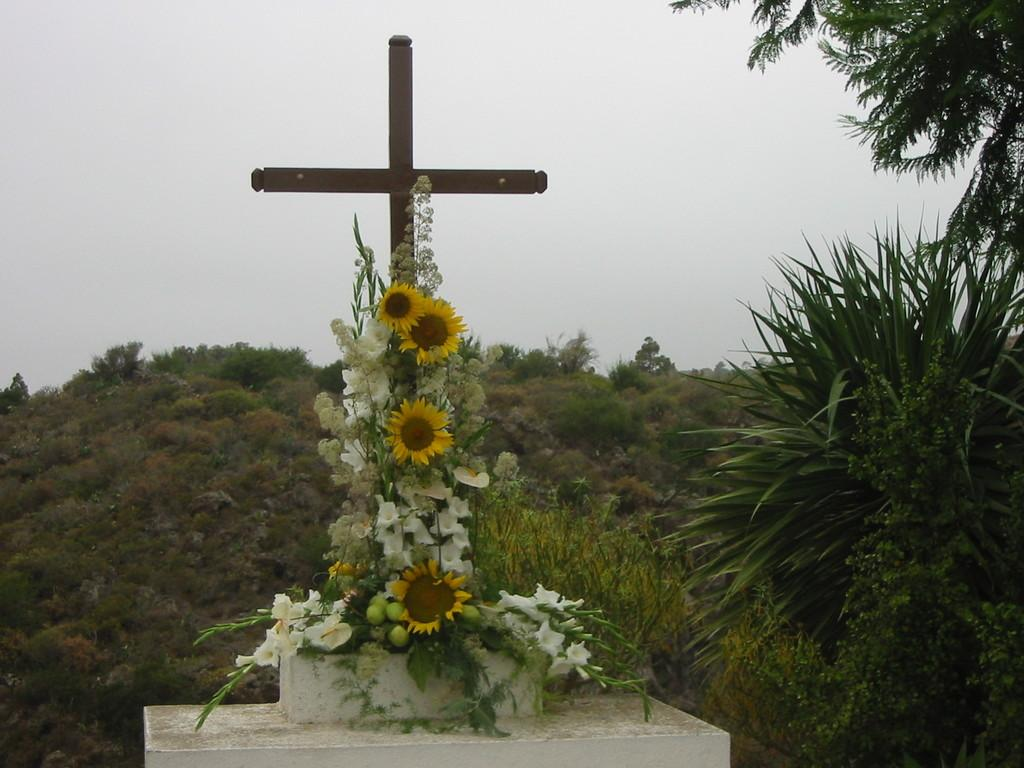What religious symbol is present in the image? There is a cross in the image. What type of plants can be seen in the image? There are flowers and leaves on a platform in the image. What is visible in the background of the image? There are trees and the sky in the background of the image. How many fingers can be seen touching the cross in the image? There are no fingers touching the cross in the image. What type of kitten is sitting on the leaves in the image? There is no kitten present in the image; it only features a cross, flowers, leaves, trees, and the sky. 